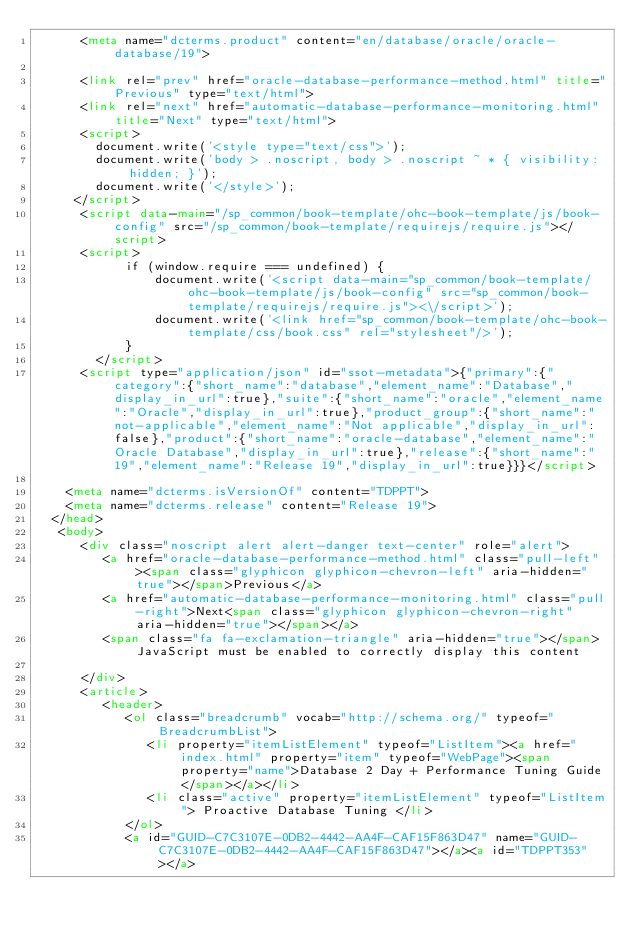Convert code to text. <code><loc_0><loc_0><loc_500><loc_500><_HTML_>      <meta name="dcterms.product" content="en/database/oracle/oracle-database/19">
      
      <link rel="prev" href="oracle-database-performance-method.html" title="Previous" type="text/html">
      <link rel="next" href="automatic-database-performance-monitoring.html" title="Next" type="text/html">
      <script>
        document.write('<style type="text/css">');
        document.write('body > .noscript, body > .noscript ~ * { visibility: hidden; }');
        document.write('</style>');
     </script>
      <script data-main="/sp_common/book-template/ohc-book-template/js/book-config" src="/sp_common/book-template/requirejs/require.js"></script>
      <script>
            if (window.require === undefined) {
                document.write('<script data-main="sp_common/book-template/ohc-book-template/js/book-config" src="sp_common/book-template/requirejs/require.js"><\/script>');
                document.write('<link href="sp_common/book-template/ohc-book-template/css/book.css" rel="stylesheet"/>');
            }
        </script>
      <script type="application/json" id="ssot-metadata">{"primary":{"category":{"short_name":"database","element_name":"Database","display_in_url":true},"suite":{"short_name":"oracle","element_name":"Oracle","display_in_url":true},"product_group":{"short_name":"not-applicable","element_name":"Not applicable","display_in_url":false},"product":{"short_name":"oracle-database","element_name":"Oracle Database","display_in_url":true},"release":{"short_name":"19","element_name":"Release 19","display_in_url":true}}}</script>
      
    <meta name="dcterms.isVersionOf" content="TDPPT">
    <meta name="dcterms.release" content="Release 19">
  </head>
   <body>
      <div class="noscript alert alert-danger text-center" role="alert">
         <a href="oracle-database-performance-method.html" class="pull-left"><span class="glyphicon glyphicon-chevron-left" aria-hidden="true"></span>Previous</a>
         <a href="automatic-database-performance-monitoring.html" class="pull-right">Next<span class="glyphicon glyphicon-chevron-right" aria-hidden="true"></span></a>
         <span class="fa fa-exclamation-triangle" aria-hidden="true"></span> JavaScript must be enabled to correctly display this content
        
      </div>
      <article>
         <header>
            <ol class="breadcrumb" vocab="http://schema.org/" typeof="BreadcrumbList">
               <li property="itemListElement" typeof="ListItem"><a href="index.html" property="item" typeof="WebPage"><span property="name">Database 2 Day + Performance Tuning Guide</span></a></li>
               <li class="active" property="itemListElement" typeof="ListItem"> Proactive Database Tuning </li>
            </ol>
            <a id="GUID-C7C3107E-0DB2-4442-AA4F-CAF15F863D47" name="GUID-C7C3107E-0DB2-4442-AA4F-CAF15F863D47"></a><a id="TDPPT353"></a>
            </code> 